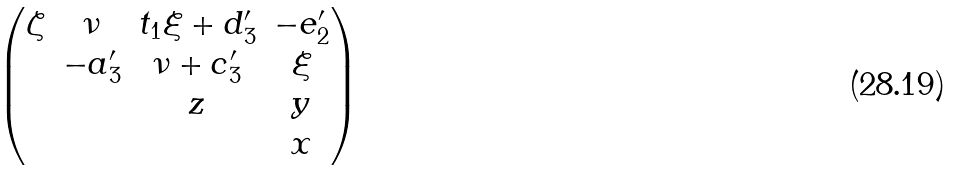<formula> <loc_0><loc_0><loc_500><loc_500>\begin{pmatrix} \zeta & \nu & t _ { 1 } \xi + d ^ { \prime } _ { 3 } & - e ^ { \prime } _ { 2 } \\ & - a ^ { \prime } _ { 3 } & \nu + c ^ { \prime } _ { 3 } & \xi \\ & & z & y \\ & & & x \end{pmatrix}</formula> 